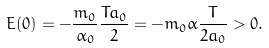Convert formula to latex. <formula><loc_0><loc_0><loc_500><loc_500>E ( 0 ) = - \frac { m _ { 0 } } { \alpha _ { 0 } } \frac { T a _ { 0 } } { 2 } = - m _ { 0 } \alpha \frac { T } { 2 a _ { 0 } } > 0 .</formula> 